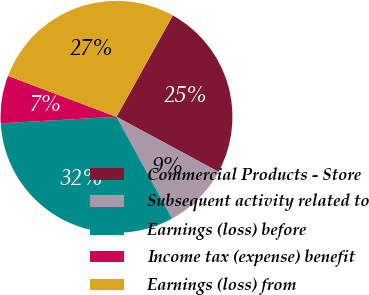<chart> <loc_0><loc_0><loc_500><loc_500><pie_chart><fcel>Commercial Products - Store<fcel>Subsequent activity related to<fcel>Earnings (loss) before<fcel>Income tax (expense) benefit<fcel>Earnings (loss) from<nl><fcel>24.8%<fcel>9.17%<fcel>32.06%<fcel>6.63%<fcel>27.34%<nl></chart> 